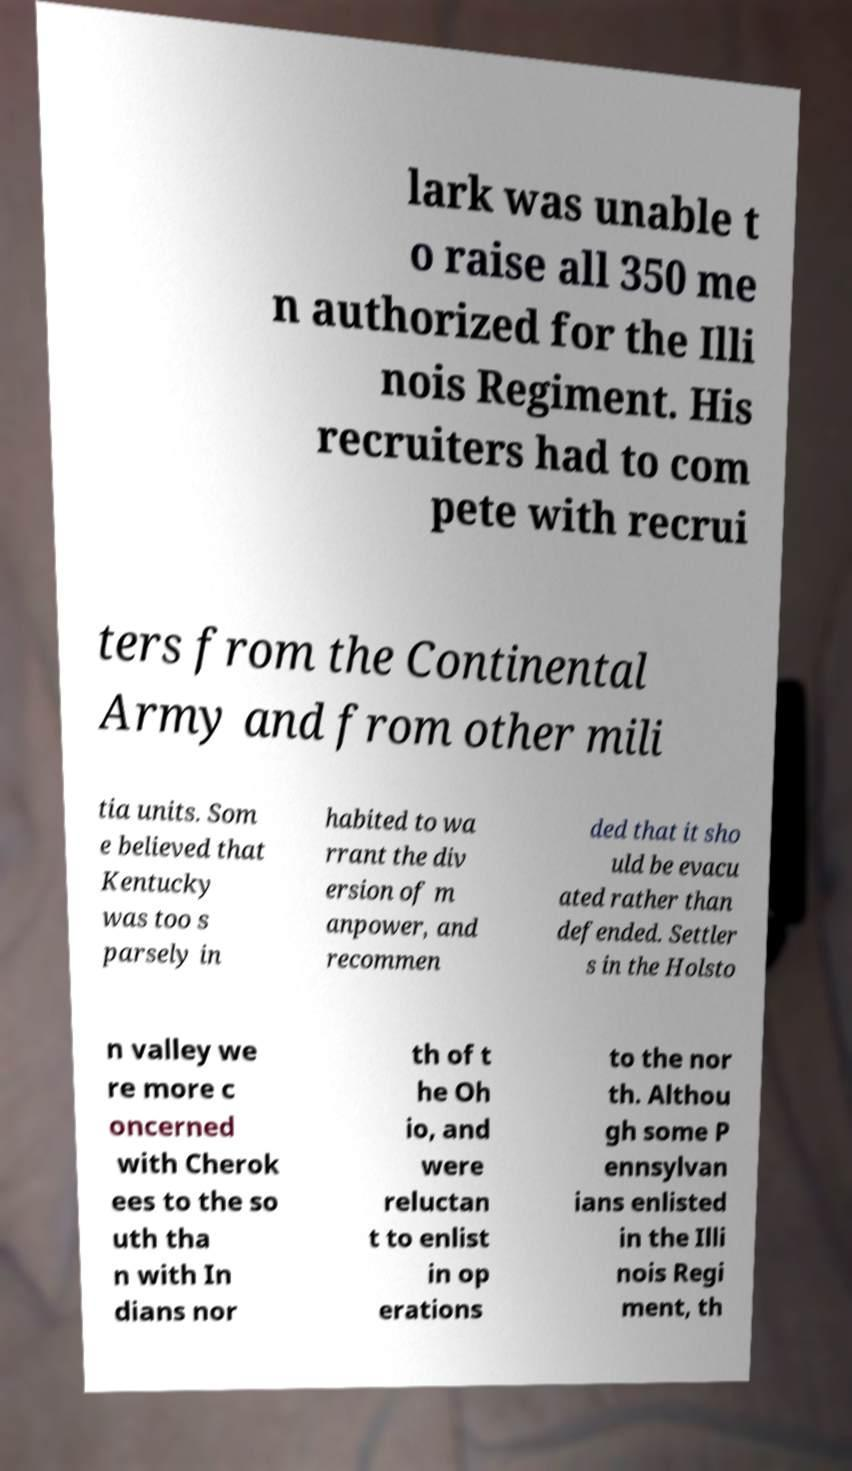Could you extract and type out the text from this image? lark was unable t o raise all 350 me n authorized for the Illi nois Regiment. His recruiters had to com pete with recrui ters from the Continental Army and from other mili tia units. Som e believed that Kentucky was too s parsely in habited to wa rrant the div ersion of m anpower, and recommen ded that it sho uld be evacu ated rather than defended. Settler s in the Holsto n valley we re more c oncerned with Cherok ees to the so uth tha n with In dians nor th of t he Oh io, and were reluctan t to enlist in op erations to the nor th. Althou gh some P ennsylvan ians enlisted in the Illi nois Regi ment, th 